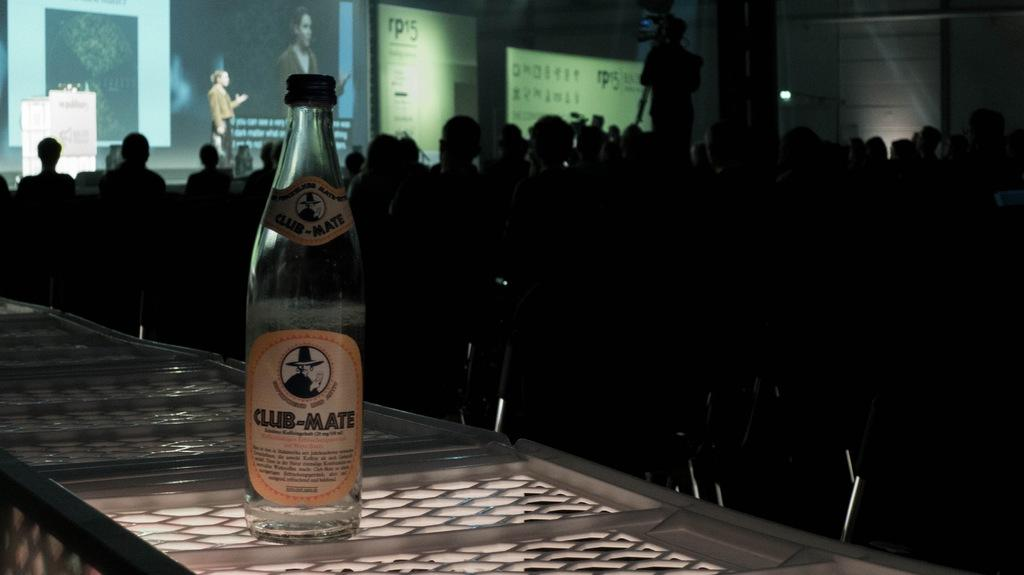<image>
Render a clear and concise summary of the photo. A large crowd of people are cast in a dark shadow with a bottle of Club-Mate at the forefront of the image. 